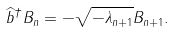<formula> <loc_0><loc_0><loc_500><loc_500>\widehat { b } ^ { \dagger } B _ { n } = - \sqrt { - \lambda _ { n + 1 } } B _ { n + 1 } .</formula> 